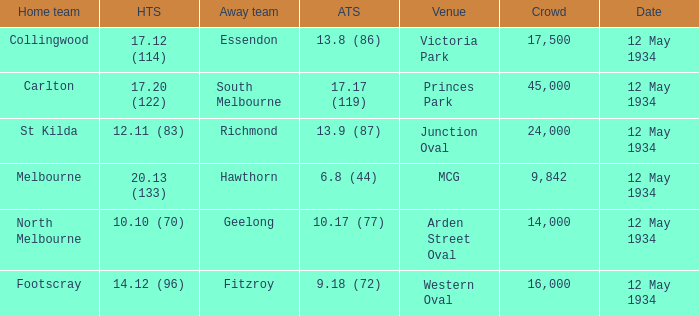Give me the full table as a dictionary. {'header': ['Home team', 'HTS', 'Away team', 'ATS', 'Venue', 'Crowd', 'Date'], 'rows': [['Collingwood', '17.12 (114)', 'Essendon', '13.8 (86)', 'Victoria Park', '17,500', '12 May 1934'], ['Carlton', '17.20 (122)', 'South Melbourne', '17.17 (119)', 'Princes Park', '45,000', '12 May 1934'], ['St Kilda', '12.11 (83)', 'Richmond', '13.9 (87)', 'Junction Oval', '24,000', '12 May 1934'], ['Melbourne', '20.13 (133)', 'Hawthorn', '6.8 (44)', 'MCG', '9,842', '12 May 1934'], ['North Melbourne', '10.10 (70)', 'Geelong', '10.17 (77)', 'Arden Street Oval', '14,000', '12 May 1934'], ['Footscray', '14.12 (96)', 'Fitzroy', '9.18 (72)', 'Western Oval', '16,000', '12 May 1934']]} Which home team played the Away team from Richmond? St Kilda. 